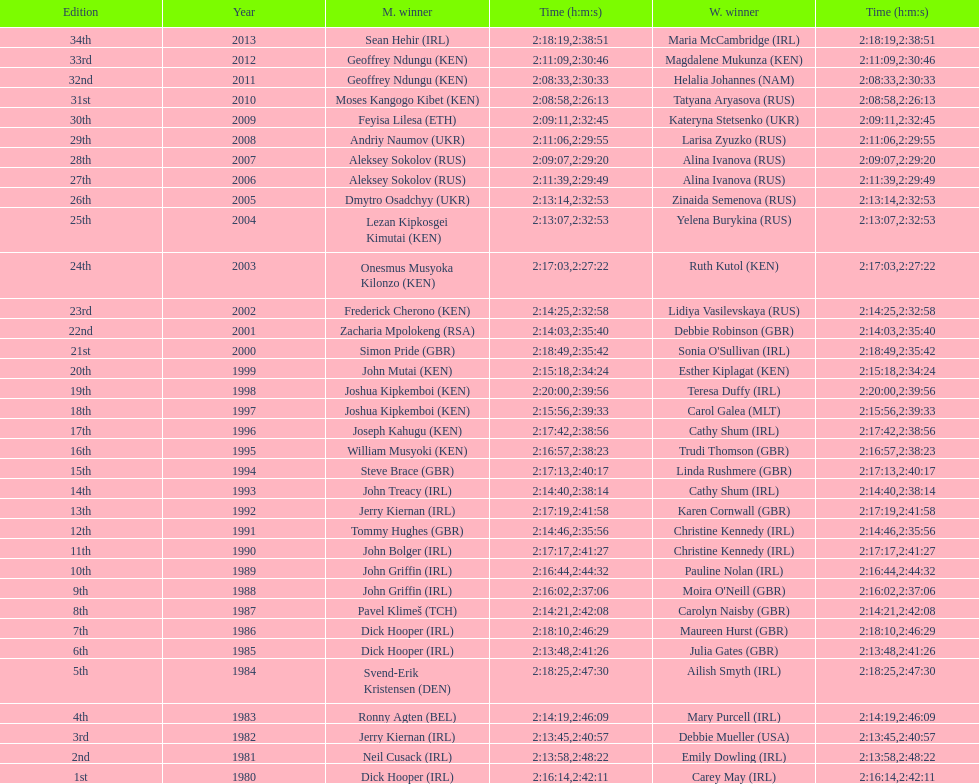How many women's victors are from kenya? 3. 